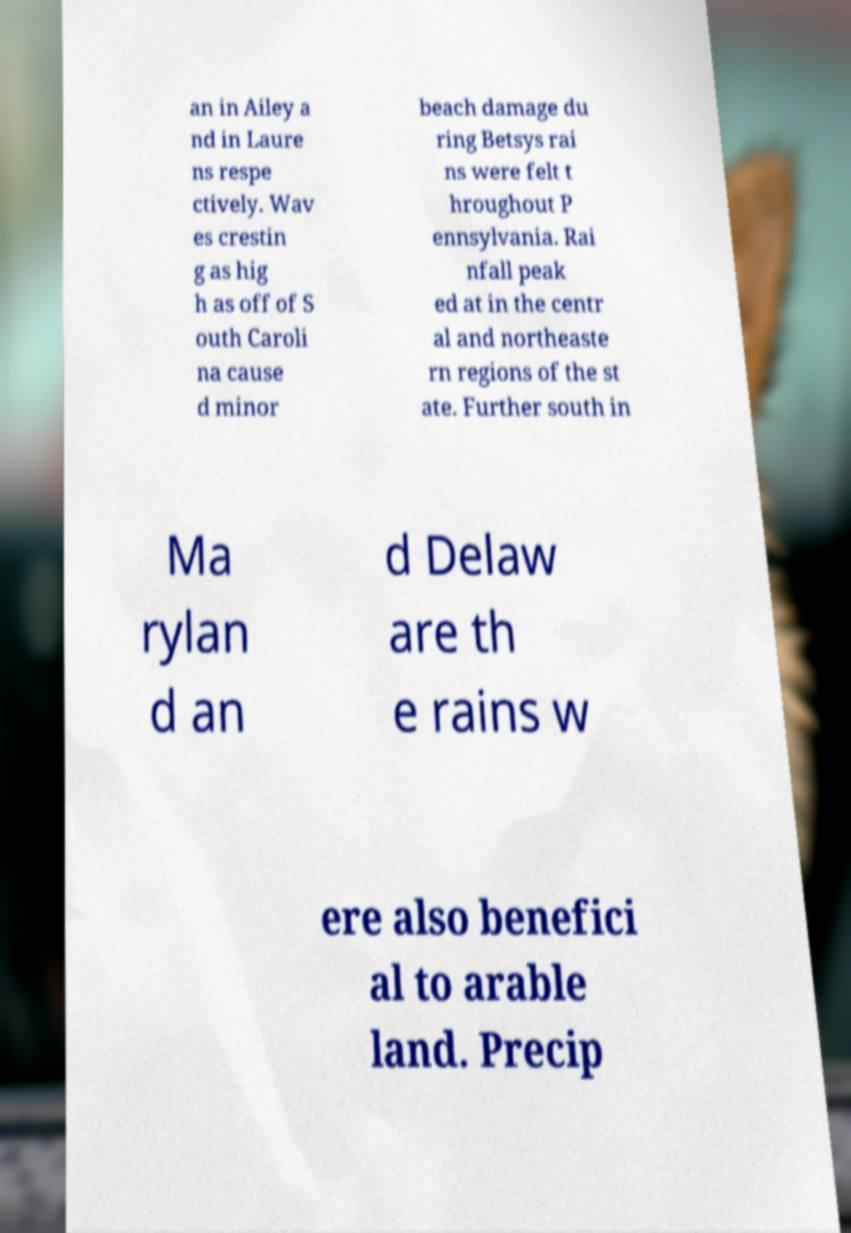I need the written content from this picture converted into text. Can you do that? an in Ailey a nd in Laure ns respe ctively. Wav es crestin g as hig h as off of S outh Caroli na cause d minor beach damage du ring Betsys rai ns were felt t hroughout P ennsylvania. Rai nfall peak ed at in the centr al and northeaste rn regions of the st ate. Further south in Ma rylan d an d Delaw are th e rains w ere also benefici al to arable land. Precip 